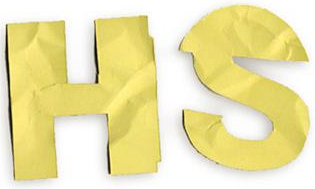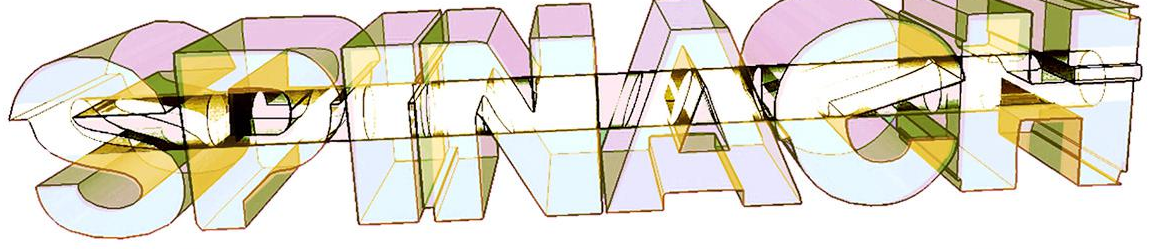Read the text from these images in sequence, separated by a semicolon. HS; SPINAeH 